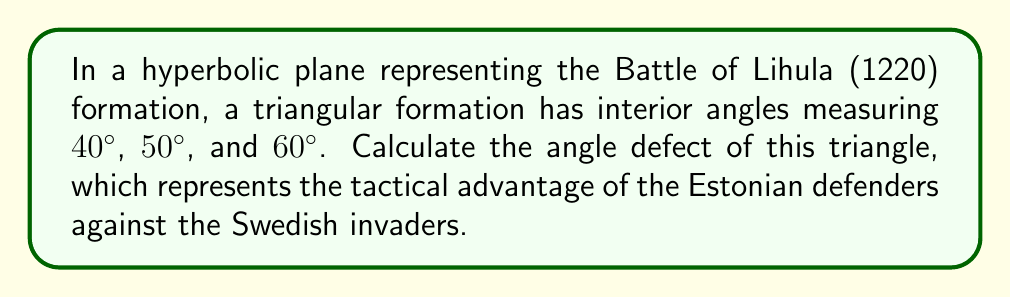Provide a solution to this math problem. To solve this problem, we need to follow these steps:

1. Recall that in Euclidean geometry, the sum of interior angles of a triangle is always 180°.

2. In hyperbolic geometry, the sum of interior angles of a triangle is always less than 180°. The difference between 180° and the actual sum is called the angle defect.

3. Calculate the sum of the given interior angles:
   $$ 40° + 50° + 60° = 150° $$

4. Calculate the angle defect by subtracting this sum from 180°:
   $$ \text{Angle Defect} = 180° - (40° + 50° + 60°) = 180° - 150° = 30° $$

5. This 30° angle defect represents the tactical advantage of the Estonian defenders, as it symbolizes the curvature of the hyperbolic plane that affects the battle formation.

[asy]
import geometry;

size(200);
pair A = (0,0), B = (2,0), C = (1,1.5);
draw(A--B--C--cycle);
label("40°", A, SW);
label("50°", B, SE);
label("60°", C, N);
label("Angle Defect: 30°", (1,-0.5), S);
[/asy]
Answer: $30°$ 